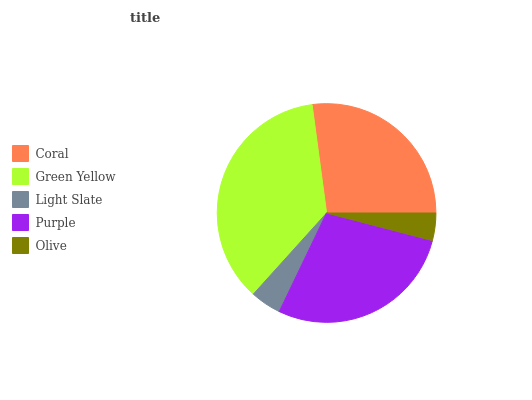Is Olive the minimum?
Answer yes or no. Yes. Is Green Yellow the maximum?
Answer yes or no. Yes. Is Light Slate the minimum?
Answer yes or no. No. Is Light Slate the maximum?
Answer yes or no. No. Is Green Yellow greater than Light Slate?
Answer yes or no. Yes. Is Light Slate less than Green Yellow?
Answer yes or no. Yes. Is Light Slate greater than Green Yellow?
Answer yes or no. No. Is Green Yellow less than Light Slate?
Answer yes or no. No. Is Coral the high median?
Answer yes or no. Yes. Is Coral the low median?
Answer yes or no. Yes. Is Purple the high median?
Answer yes or no. No. Is Light Slate the low median?
Answer yes or no. No. 